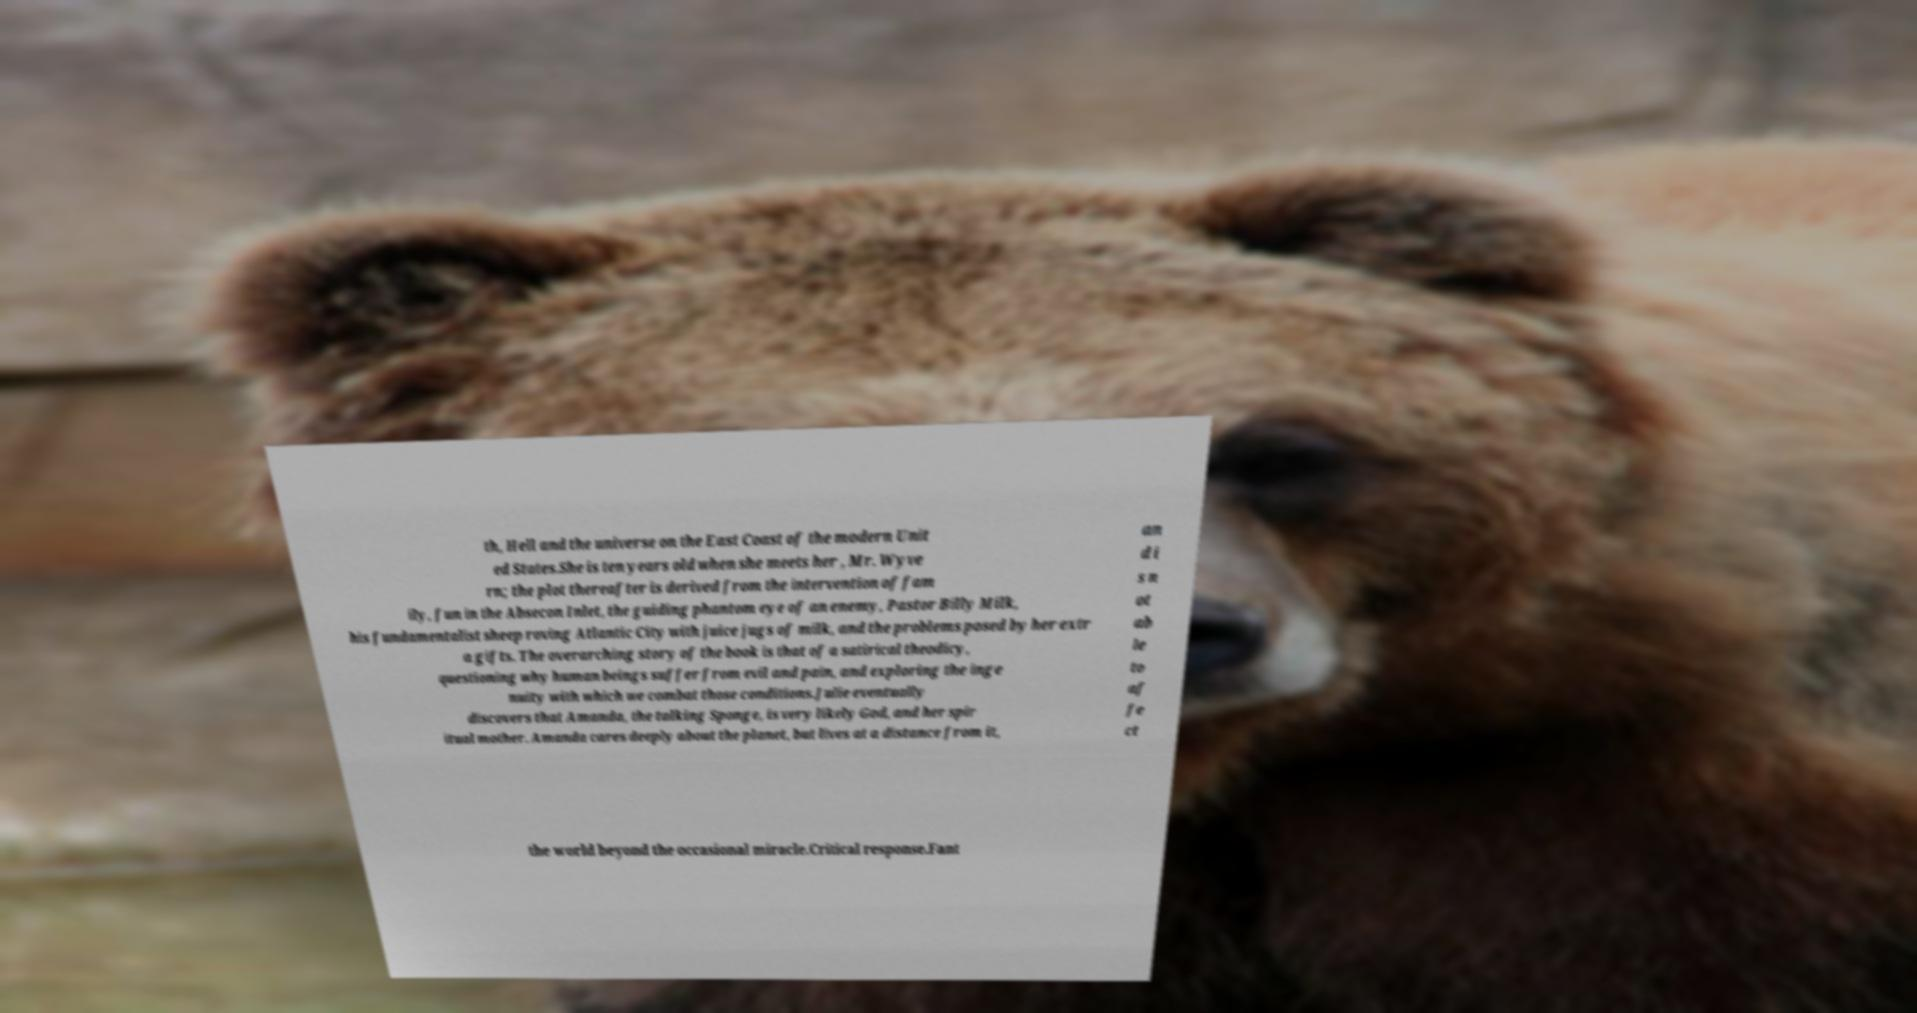Could you assist in decoding the text presented in this image and type it out clearly? th, Hell and the universe on the East Coast of the modern Unit ed States.She is ten years old when she meets her , Mr. Wyve rn; the plot thereafter is derived from the intervention of fam ily, fun in the Absecon Inlet, the guiding phantom eye of an enemy, Pastor Billy Milk, his fundamentalist sheep roving Atlantic City with juice jugs of milk, and the problems posed by her extr a gifts. The overarching story of the book is that of a satirical theodicy, questioning why human beings suffer from evil and pain, and exploring the inge nuity with which we combat those conditions.Julie eventually discovers that Amanda, the talking Sponge, is very likely God, and her spir itual mother. Amanda cares deeply about the planet, but lives at a distance from it, an d i s n ot ab le to af fe ct the world beyond the occasional miracle.Critical response.Fant 